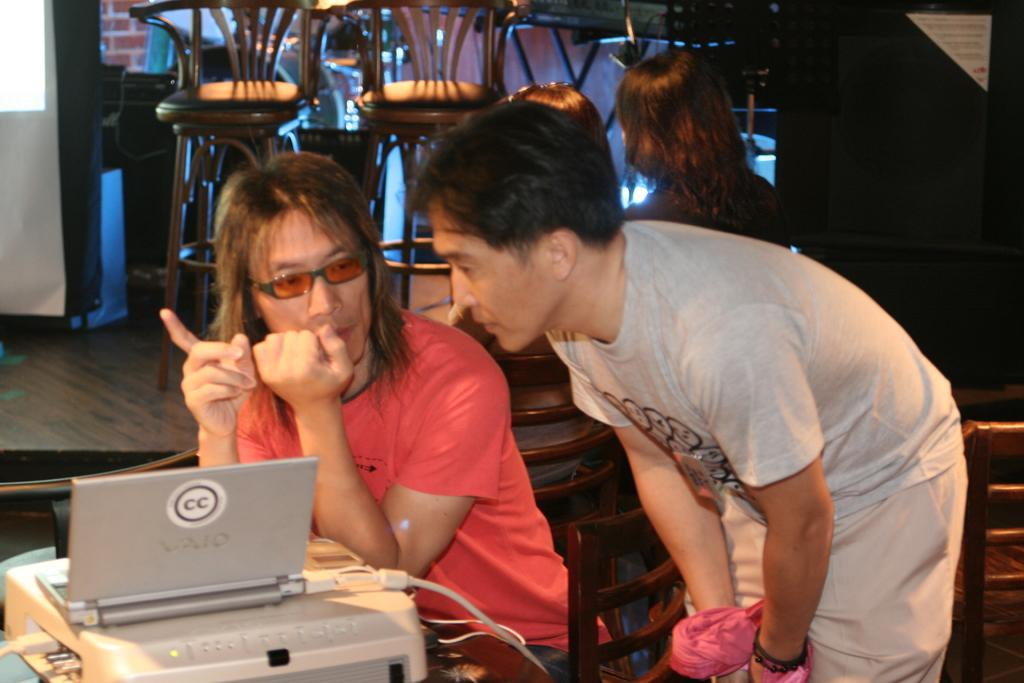<image>
Give a short and clear explanation of the subsequent image. Two people are talking and looking at a laptop that says CC. 